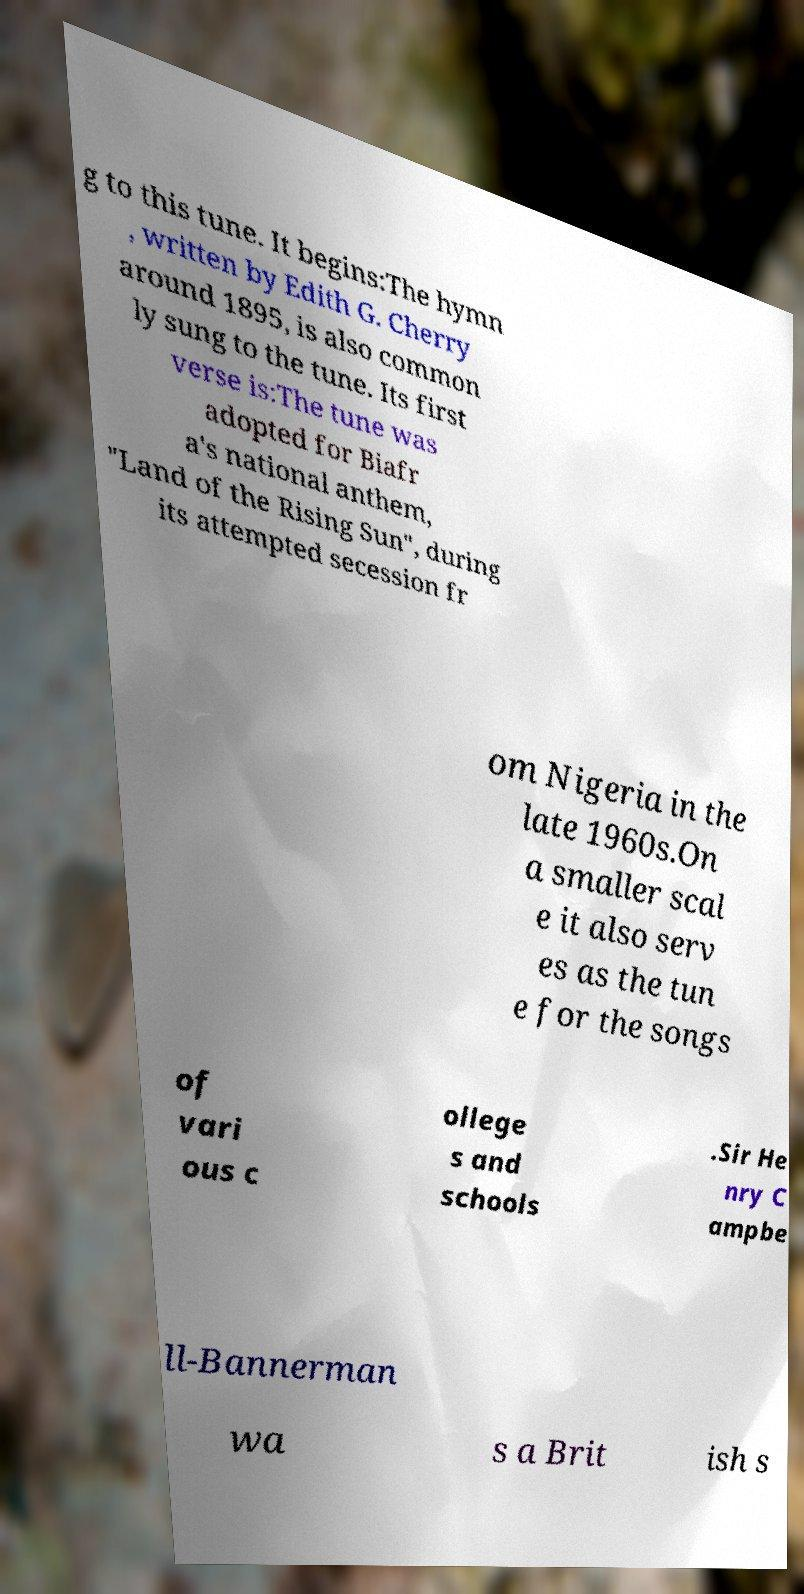Can you read and provide the text displayed in the image?This photo seems to have some interesting text. Can you extract and type it out for me? g to this tune. It begins:The hymn , written by Edith G. Cherry around 1895, is also common ly sung to the tune. Its first verse is:The tune was adopted for Biafr a's national anthem, "Land of the Rising Sun", during its attempted secession fr om Nigeria in the late 1960s.On a smaller scal e it also serv es as the tun e for the songs of vari ous c ollege s and schools .Sir He nry C ampbe ll-Bannerman wa s a Brit ish s 